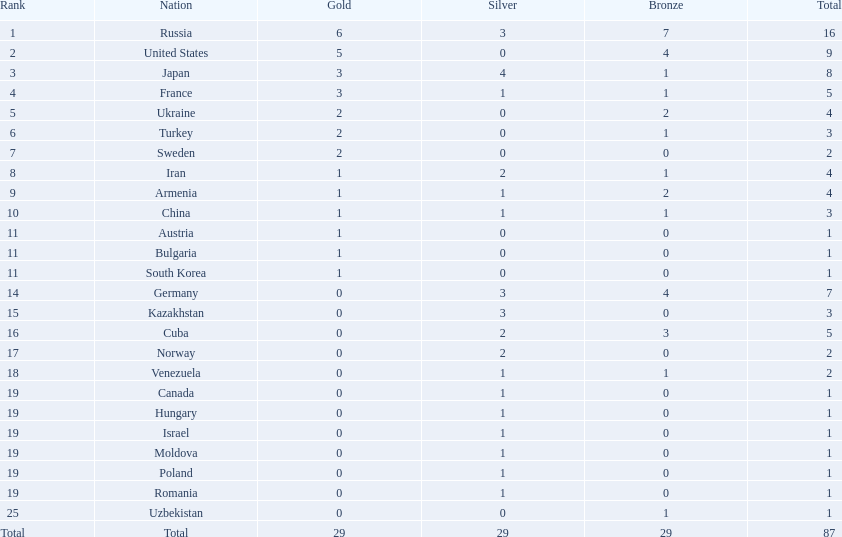How many countries competed? Israel. How many total medals did russia win? 16. What country won only 1 medal? Uzbekistan. 